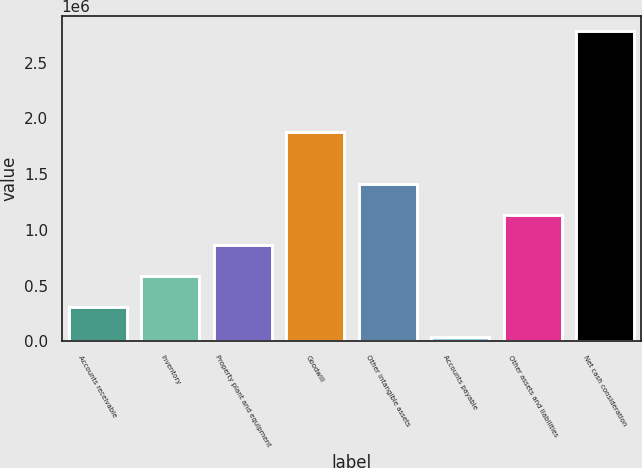Convert chart to OTSL. <chart><loc_0><loc_0><loc_500><loc_500><bar_chart><fcel>Accounts receivable<fcel>Inventory<fcel>Property plant and equipment<fcel>Goodwill<fcel>Other intangible assets<fcel>Accounts payable<fcel>Other assets and liabilities<fcel>Net cash consideration<nl><fcel>310616<fcel>585313<fcel>860010<fcel>1.87458e+06<fcel>1.4094e+06<fcel>35919<fcel>1.13471e+06<fcel>2.78289e+06<nl></chart> 